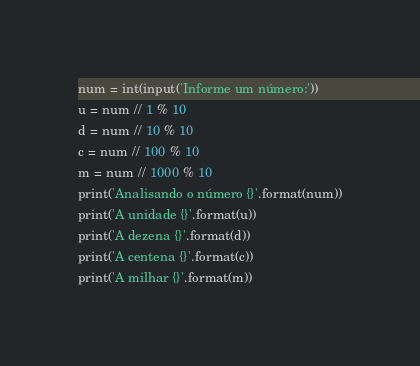Convert code to text. <code><loc_0><loc_0><loc_500><loc_500><_Python_>num = int(input('Informe um número:'))
u = num // 1 % 10
d = num // 10 % 10
c = num // 100 % 10
m = num // 1000 % 10
print('Analisando o número {}'.format(num))
print('A unidade {}'.format(u))
print('A dezena {}'.format(d))
print('A centena {}'.format(c))
print('A milhar {}'.format(m))
</code> 